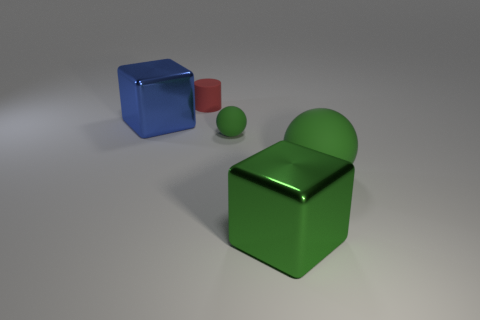Add 2 cyan rubber things. How many objects exist? 7 Subtract all spheres. How many objects are left? 3 Subtract 2 spheres. How many spheres are left? 0 Subtract all yellow blocks. Subtract all blue balls. How many blocks are left? 2 Subtract all big purple matte cubes. Subtract all metallic cubes. How many objects are left? 3 Add 1 large green objects. How many large green objects are left? 3 Add 1 metal things. How many metal things exist? 3 Subtract all green cubes. How many cubes are left? 1 Subtract 0 brown cubes. How many objects are left? 5 